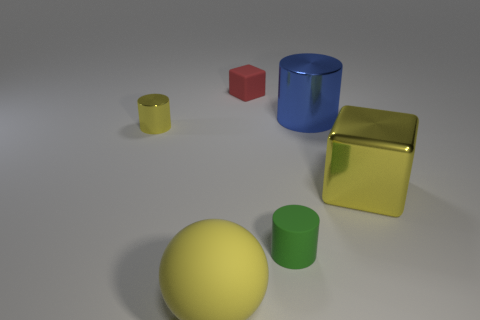How many tiny cylinders are on the right side of the cube left of the tiny green matte object?
Provide a succinct answer. 1. Does the small thing that is behind the big blue shiny object have the same shape as the large metallic object on the left side of the yellow shiny cube?
Offer a very short reply. No. What number of yellow metal things are to the right of the large yellow matte ball?
Provide a short and direct response. 1. Do the object that is on the left side of the large sphere and the blue cylinder have the same material?
Offer a terse response. Yes. What color is the other small rubber thing that is the same shape as the small yellow thing?
Keep it short and to the point. Green. The small green rubber object is what shape?
Offer a very short reply. Cylinder. What number of things are small gray metal balls or big yellow matte spheres?
Give a very brief answer. 1. There is a small cylinder to the right of the big yellow ball; is it the same color as the small matte thing that is behind the blue cylinder?
Your answer should be very brief. No. How many other objects are there of the same shape as the big yellow rubber object?
Your response must be concise. 0. Is there a large purple metallic thing?
Keep it short and to the point. No. 